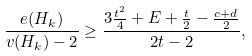<formula> <loc_0><loc_0><loc_500><loc_500>\frac { e ( H _ { k } ) } { v ( H _ { k } ) - 2 } \geq \frac { 3 \frac { t ^ { 2 } } { 4 } + E + \frac { t } { 2 } - \frac { c + d } { 2 } } { 2 t - 2 } ,</formula> 